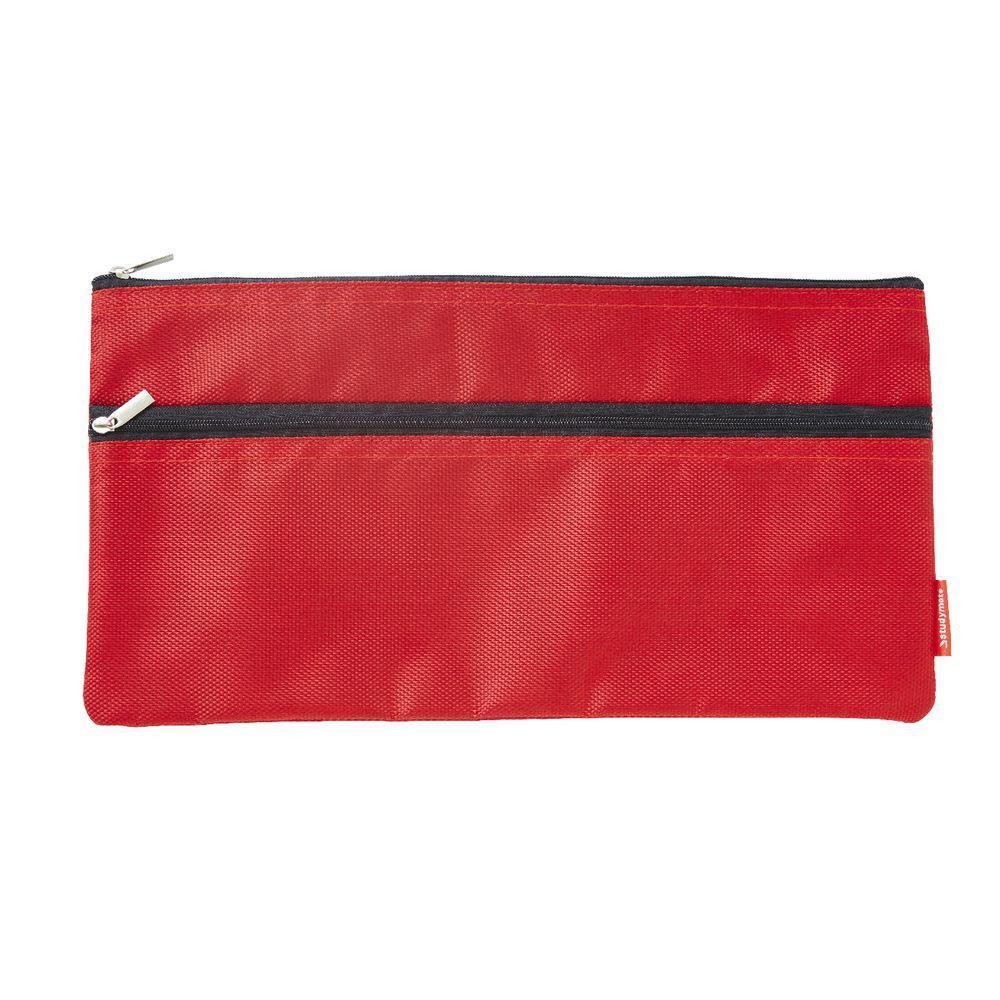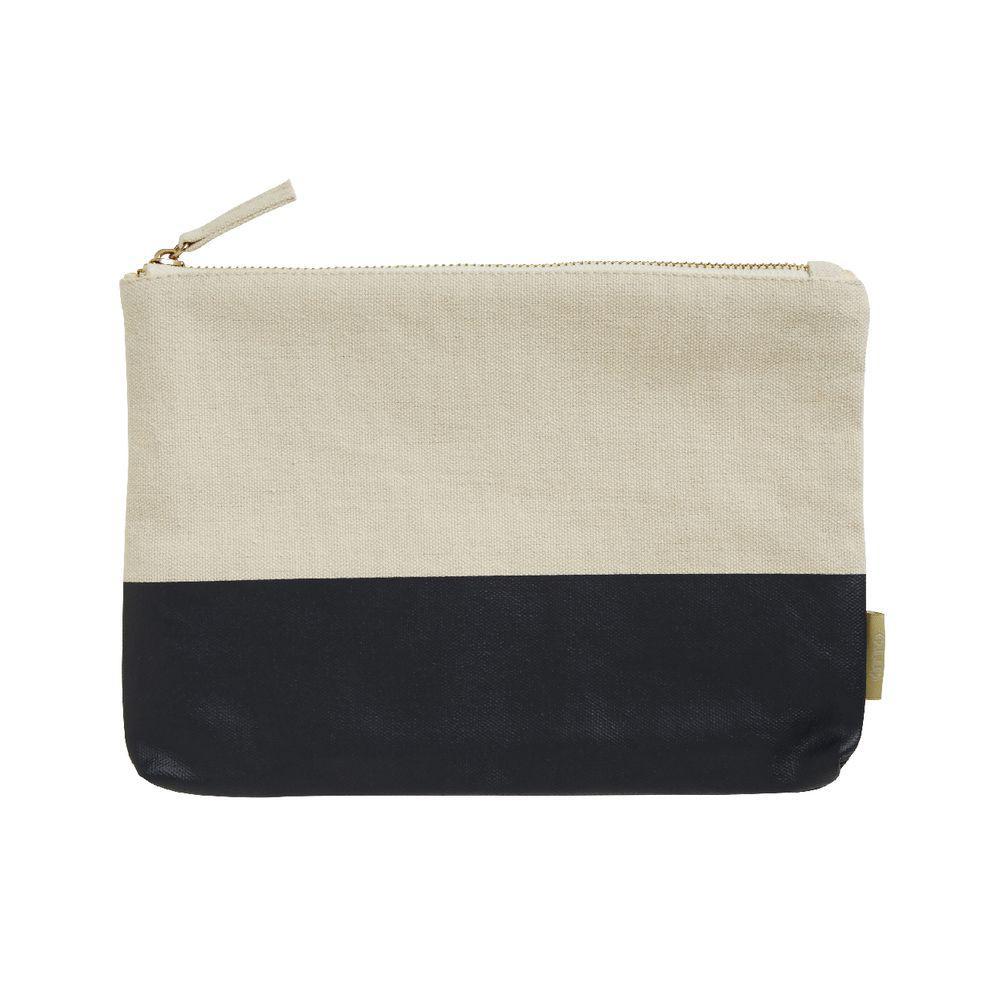The first image is the image on the left, the second image is the image on the right. For the images shown, is this caption "There is a grey tag on the pencil case in one of the images." true? Answer yes or no. No. The first image is the image on the left, the second image is the image on the right. For the images displayed, is the sentence "Each case has a single zipper and a rectangular shape with non-rounded bottom corners, and one case has a gray card on the front." factually correct? Answer yes or no. No. 